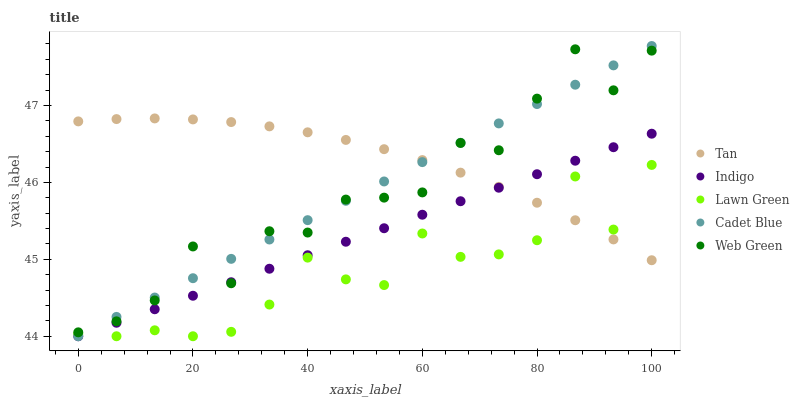Does Lawn Green have the minimum area under the curve?
Answer yes or no. Yes. Does Tan have the maximum area under the curve?
Answer yes or no. Yes. Does Cadet Blue have the minimum area under the curve?
Answer yes or no. No. Does Cadet Blue have the maximum area under the curve?
Answer yes or no. No. Is Indigo the smoothest?
Answer yes or no. Yes. Is Web Green the roughest?
Answer yes or no. Yes. Is Tan the smoothest?
Answer yes or no. No. Is Tan the roughest?
Answer yes or no. No. Does Lawn Green have the lowest value?
Answer yes or no. Yes. Does Tan have the lowest value?
Answer yes or no. No. Does Cadet Blue have the highest value?
Answer yes or no. Yes. Does Tan have the highest value?
Answer yes or no. No. Is Lawn Green less than Web Green?
Answer yes or no. Yes. Is Web Green greater than Lawn Green?
Answer yes or no. Yes. Does Web Green intersect Tan?
Answer yes or no. Yes. Is Web Green less than Tan?
Answer yes or no. No. Is Web Green greater than Tan?
Answer yes or no. No. Does Lawn Green intersect Web Green?
Answer yes or no. No. 